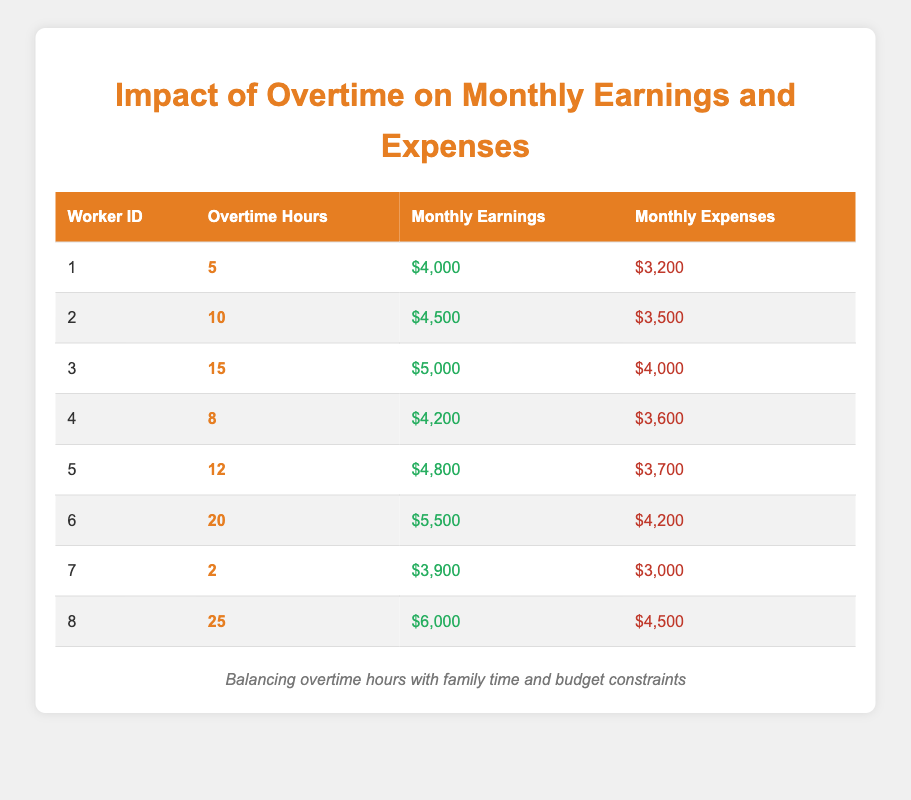What is the monthly earnings of the worker with 15 overtime hours? The worker with 15 overtime hours is worker ID 3, whose monthly earnings are listed as $5,000 in the table.
Answer: $5,000 How many workers have monthly expenses greater than $4,000? Upon reviewing the expenses for all workers, worker IDs 3, 6, and 8 have monthly expenses of $4,000, $4,200, and $4,500 respectively. That's a total of 3 workers.
Answer: 3 What is the total monthly earnings of all workers who worked more than 15 overtime hours? Looking at the table, only worker ID 6 (20 hours) and worker ID 8 (25 hours) worked more than 15 hours. Their monthly earnings are $5,500 and $6,000 respectively. The total is $5,500 + $6,000 = $11,500.
Answer: $11,500 Is there a worker who earns more than $5,000 while having less than $4,000 in expenses? Reviewing the table, no worker is listed with monthly earnings exceeding $5,000 while expenses remain below $4,000. Therefore, the answer is no.
Answer: No What is the average monthly expenses of workers with overtime hours between 5 and 15? The workers with overtime hours within this range are worker IDs 1, 4, and 5. Their expenses are $3,200, $3,600, and $3,700 respectively. The total expenses are $3,200 + $3,600 + $3,700 = $10,500. Dividing by 3 gives an average of $10,500 / 3 = $3,500.
Answer: $3,500 How much more do workers with 20 overtime hours earn compared to those with only 2 overtime hours? Worker ID 6 has 20 overtime hours and earns $5,500, while worker ID 7 has 2 overtime hours earning $3,900. The difference in earnings is $5,500 - $3,900 = $1,600.
Answer: $1,600 Which worker has the highest monthly expenses, and what is that amount? After examining the expenses, worker ID 8 has monthly expenses of $4,500, which is greater than the expenses of all other workers, making it the highest.
Answer: $4,500 